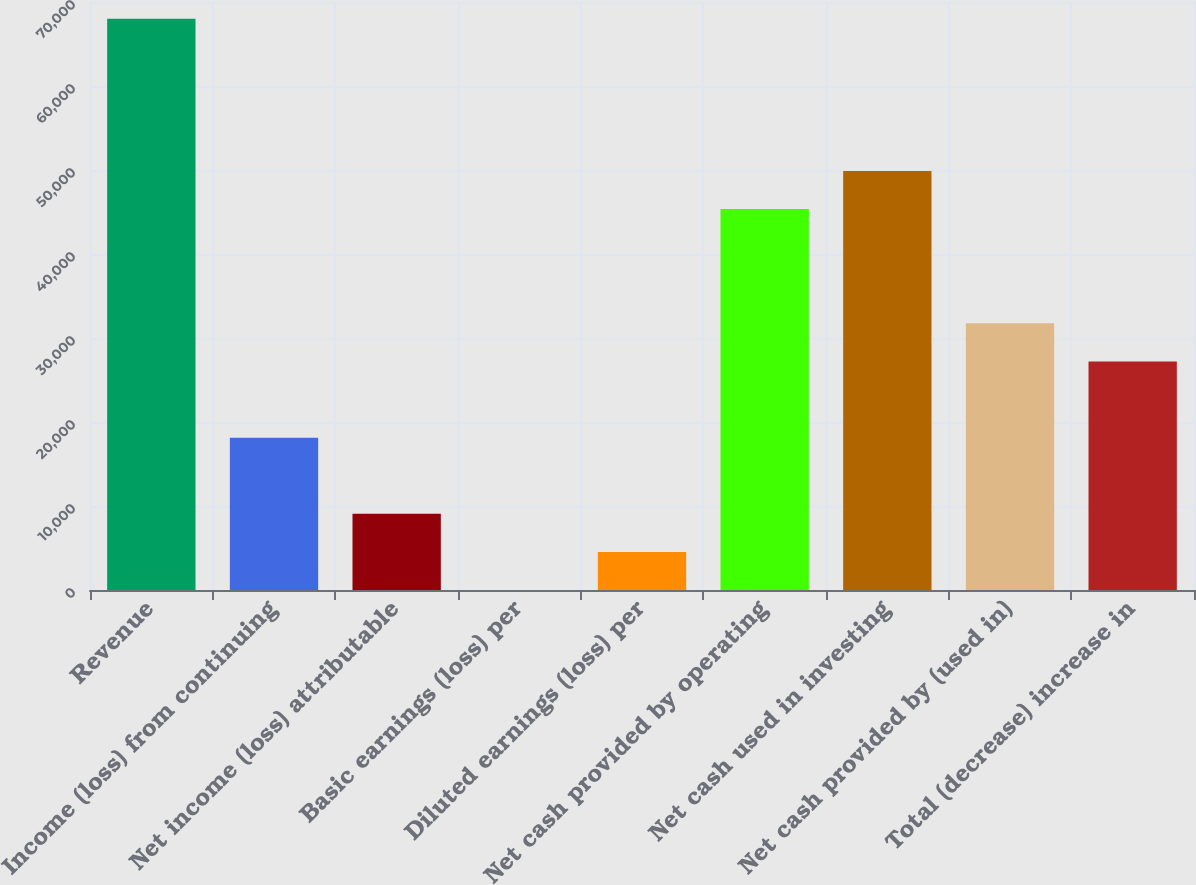Convert chart. <chart><loc_0><loc_0><loc_500><loc_500><bar_chart><fcel>Revenue<fcel>Income (loss) from continuing<fcel>Net income (loss) attributable<fcel>Basic earnings (loss) per<fcel>Diluted earnings (loss) per<fcel>Net cash provided by operating<fcel>Net cash used in investing<fcel>Net cash provided by (used in)<fcel>Total (decrease) increase in<nl><fcel>68018.9<fcel>18138.4<fcel>9069.25<fcel>0.07<fcel>4534.66<fcel>45346<fcel>49880.6<fcel>31742.2<fcel>27207.6<nl></chart> 